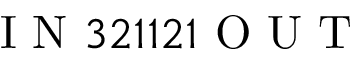<formula> <loc_0><loc_0><loc_500><loc_500>I N 3 2 1 1 2 1 O U T</formula> 